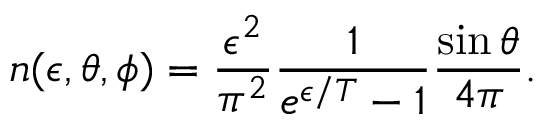<formula> <loc_0><loc_0><loc_500><loc_500>n ( \epsilon , \theta , \phi ) = \frac { \epsilon ^ { 2 } } { \pi ^ { 2 } } \frac { 1 } { e ^ { \epsilon / T } - 1 } \frac { \sin \theta } { 4 \pi } .</formula> 